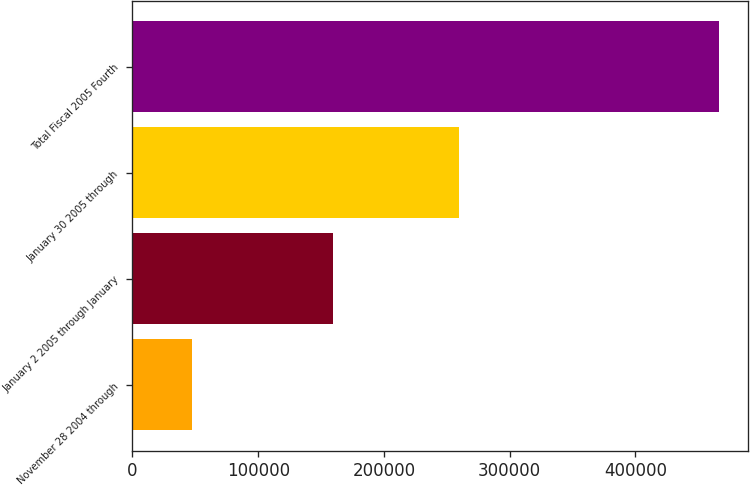Convert chart. <chart><loc_0><loc_0><loc_500><loc_500><bar_chart><fcel>November 28 2004 through<fcel>January 2 2005 through January<fcel>January 30 2005 through<fcel>Total Fiscal 2005 Fourth<nl><fcel>47313<fcel>159348<fcel>259870<fcel>466531<nl></chart> 